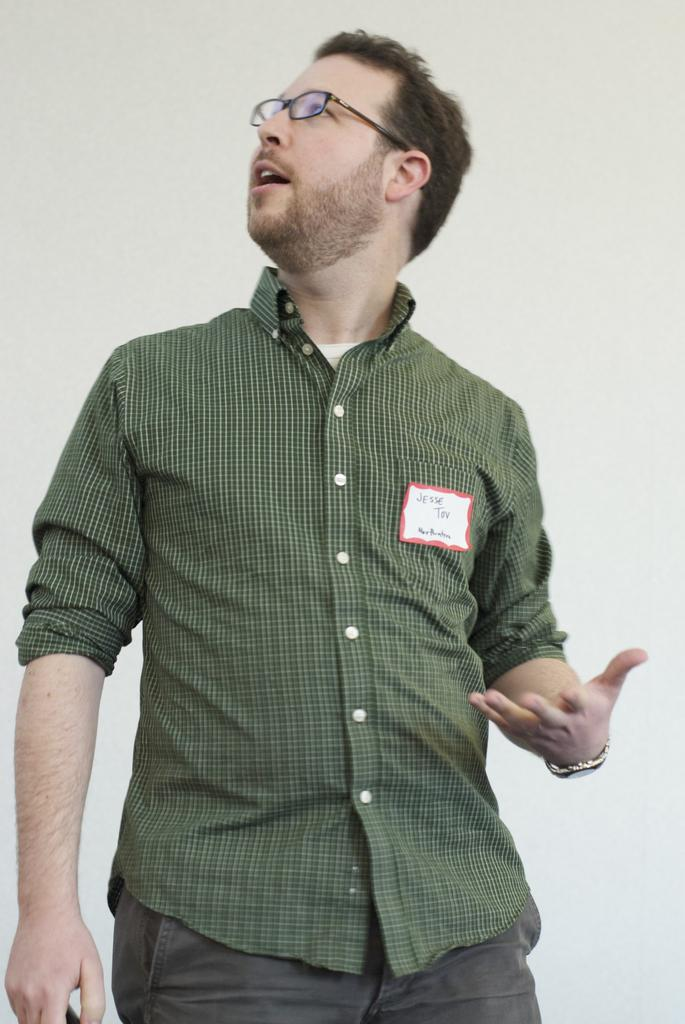What is the main subject in the foreground of the image? There is a man in the foreground of the image. What is the man wearing in the image? The man is wearing a green color shirt. What can be seen in the background of the image? There is a wall in the background of the image. How does the zephyr affect the man's balance in the image? There is no mention of a zephyr or any wind in the image, so it cannot be determined how it would affect the man's balance. 